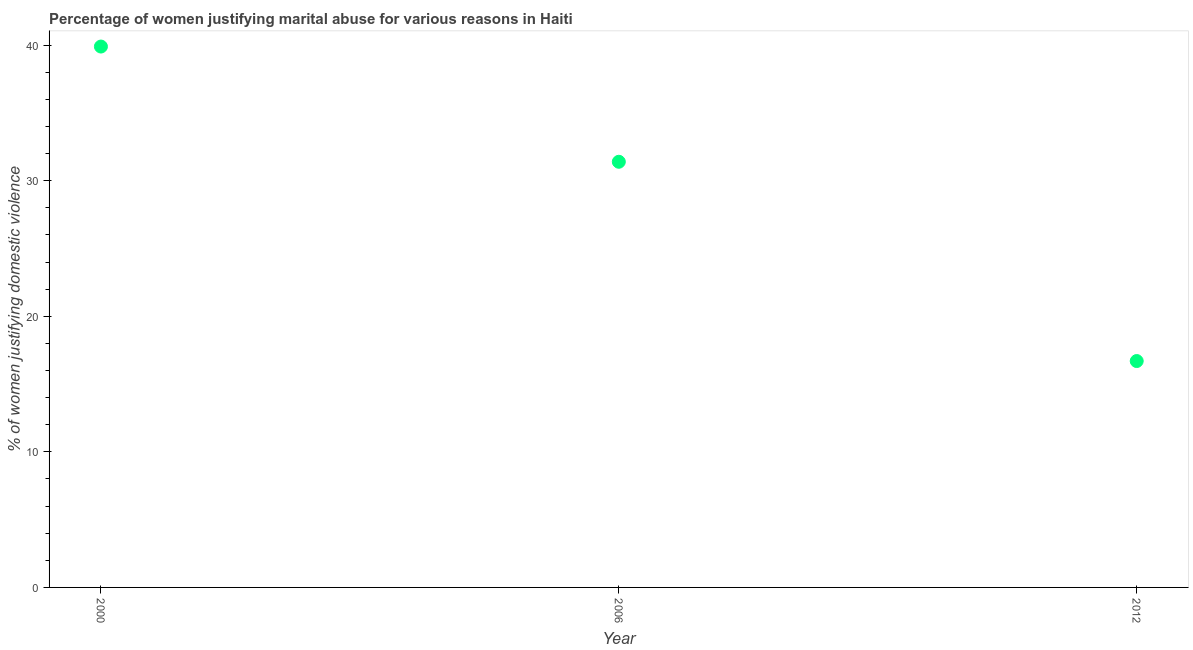What is the percentage of women justifying marital abuse in 2006?
Your answer should be very brief. 31.4. Across all years, what is the maximum percentage of women justifying marital abuse?
Make the answer very short. 39.9. In which year was the percentage of women justifying marital abuse maximum?
Give a very brief answer. 2000. In which year was the percentage of women justifying marital abuse minimum?
Provide a succinct answer. 2012. What is the sum of the percentage of women justifying marital abuse?
Provide a short and direct response. 88. What is the average percentage of women justifying marital abuse per year?
Provide a short and direct response. 29.33. What is the median percentage of women justifying marital abuse?
Give a very brief answer. 31.4. In how many years, is the percentage of women justifying marital abuse greater than 30 %?
Ensure brevity in your answer.  2. What is the ratio of the percentage of women justifying marital abuse in 2000 to that in 2006?
Provide a short and direct response. 1.27. Is the difference between the percentage of women justifying marital abuse in 2006 and 2012 greater than the difference between any two years?
Provide a short and direct response. No. Is the sum of the percentage of women justifying marital abuse in 2006 and 2012 greater than the maximum percentage of women justifying marital abuse across all years?
Ensure brevity in your answer.  Yes. What is the difference between the highest and the lowest percentage of women justifying marital abuse?
Your answer should be very brief. 23.2. Does the percentage of women justifying marital abuse monotonically increase over the years?
Provide a succinct answer. No. How many dotlines are there?
Your answer should be very brief. 1. How many years are there in the graph?
Make the answer very short. 3. What is the title of the graph?
Your answer should be compact. Percentage of women justifying marital abuse for various reasons in Haiti. What is the label or title of the X-axis?
Keep it short and to the point. Year. What is the label or title of the Y-axis?
Give a very brief answer. % of women justifying domestic violence. What is the % of women justifying domestic violence in 2000?
Your answer should be very brief. 39.9. What is the % of women justifying domestic violence in 2006?
Ensure brevity in your answer.  31.4. What is the % of women justifying domestic violence in 2012?
Make the answer very short. 16.7. What is the difference between the % of women justifying domestic violence in 2000 and 2006?
Keep it short and to the point. 8.5. What is the difference between the % of women justifying domestic violence in 2000 and 2012?
Offer a terse response. 23.2. What is the difference between the % of women justifying domestic violence in 2006 and 2012?
Your answer should be very brief. 14.7. What is the ratio of the % of women justifying domestic violence in 2000 to that in 2006?
Offer a very short reply. 1.27. What is the ratio of the % of women justifying domestic violence in 2000 to that in 2012?
Your answer should be very brief. 2.39. What is the ratio of the % of women justifying domestic violence in 2006 to that in 2012?
Offer a terse response. 1.88. 